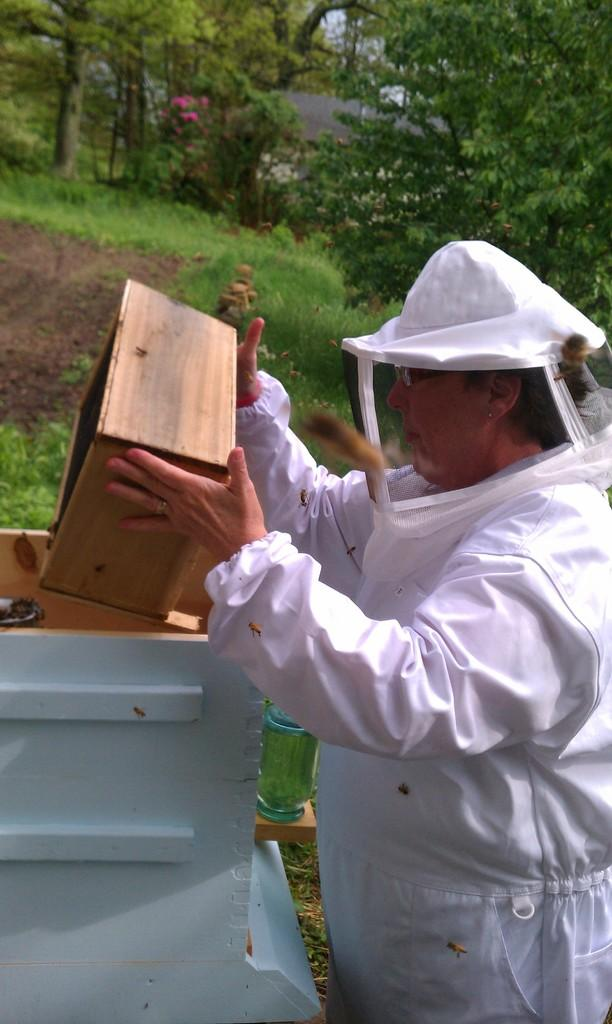Who is the person in the image? There is a man in the image. What is the man doing in the image? The man is catching a box in the image. What insects can be seen in the image? There are bees in the image. What type of vegetation is present in the image? There are trees and grass present in the image. Where is the lake located in the image? There is no lake present in the image. Can you see any steam coming from the man's hands while he catches the box? There is no steam visible in the image. 